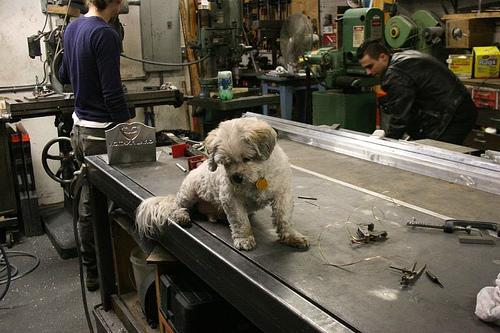What work is done in this space? mechanic 